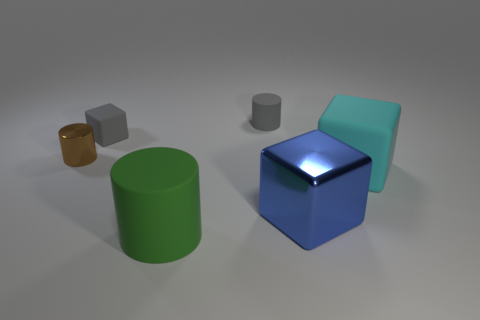Subtract all big cubes. How many cubes are left? 1 Add 2 brown objects. How many objects exist? 8 Subtract all gray blocks. How many blocks are left? 2 Subtract 3 blocks. How many blocks are left? 0 Subtract all brown cubes. Subtract all brown cylinders. How many cubes are left? 3 Subtract all tiny purple objects. Subtract all tiny brown things. How many objects are left? 5 Add 2 blue things. How many blue things are left? 3 Add 4 green matte cylinders. How many green matte cylinders exist? 5 Subtract 0 brown spheres. How many objects are left? 6 